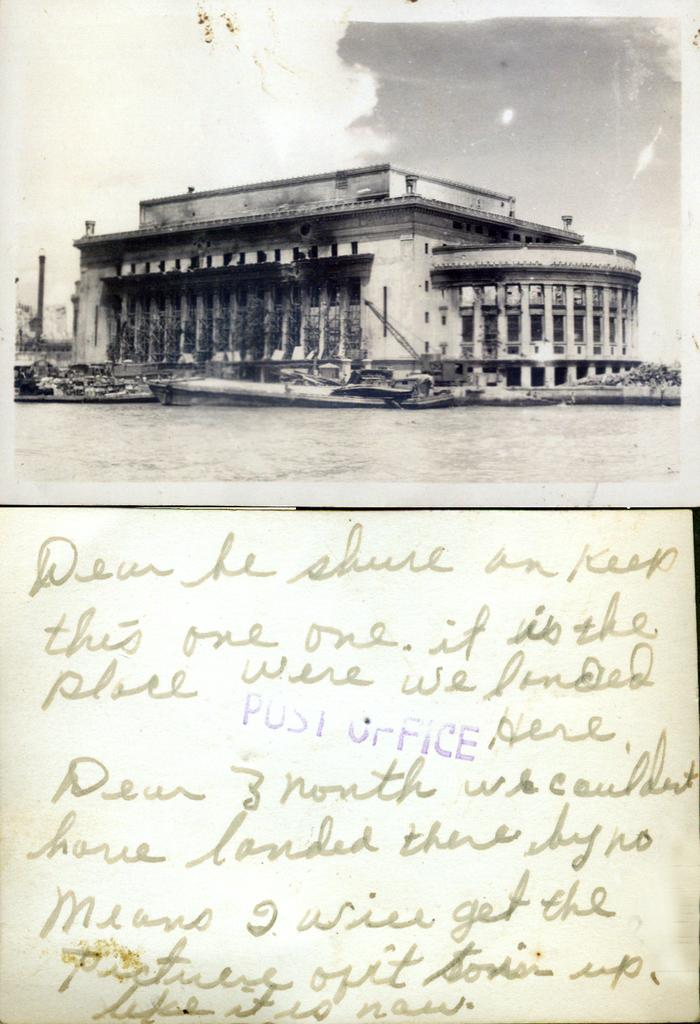<image>
Create a compact narrative representing the image presented. A hand-written note from a post card starts with the word "Dear". 